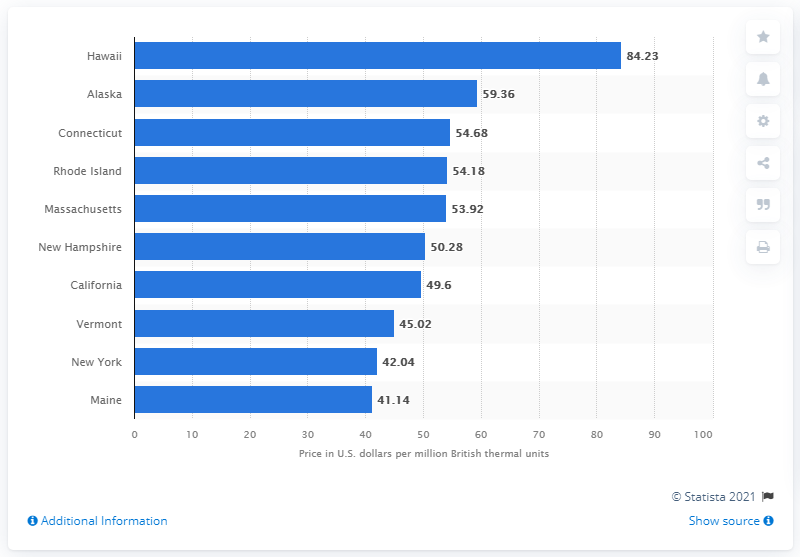Indicate a few pertinent items in this graphic. Hawaii has the highest average electricity costs for all sectors in the United States. The second most expensive place for electricity purchases was Alaska. In 2019, the average Hawaii resident and business paid $84.23 per million British thermal units. 